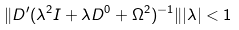<formula> <loc_0><loc_0><loc_500><loc_500>\| D ^ { \prime } ( \lambda ^ { 2 } I + \lambda D ^ { 0 } + \Omega ^ { 2 } ) ^ { - 1 } \| | \lambda | < 1</formula> 